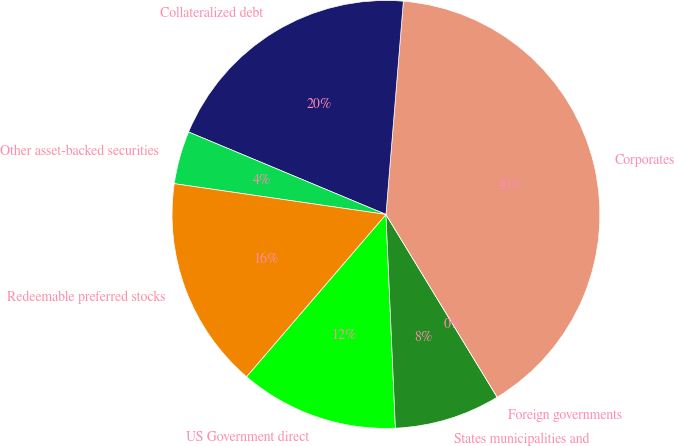Convert chart. <chart><loc_0><loc_0><loc_500><loc_500><pie_chart><fcel>US Government direct<fcel>States municipalities and<fcel>Foreign governments<fcel>Corporates<fcel>Collateralized debt<fcel>Other asset-backed securities<fcel>Redeemable preferred stocks<nl><fcel>12.0%<fcel>8.0%<fcel>0.0%<fcel>40.0%<fcel>20.0%<fcel>4.0%<fcel>16.0%<nl></chart> 